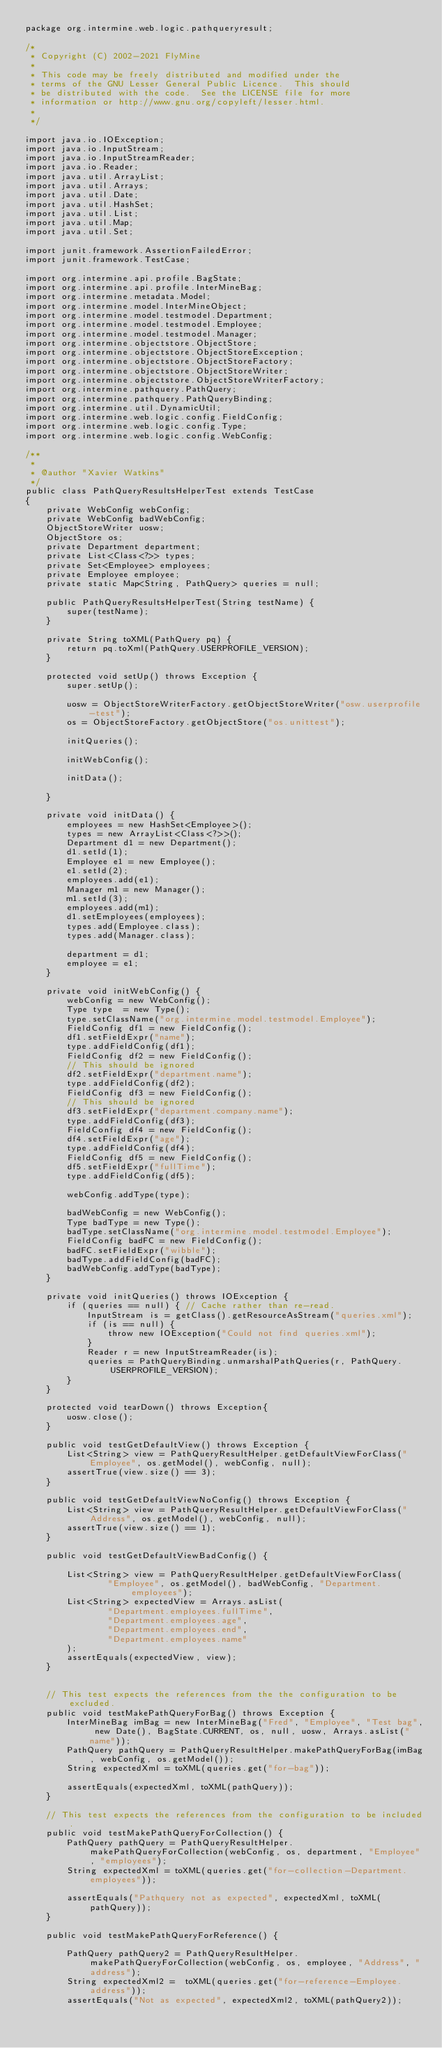<code> <loc_0><loc_0><loc_500><loc_500><_Java_>package org.intermine.web.logic.pathqueryresult;

/*
 * Copyright (C) 2002-2021 FlyMine
 *
 * This code may be freely distributed and modified under the
 * terms of the GNU Lesser General Public Licence.  This should
 * be distributed with the code.  See the LICENSE file for more
 * information or http://www.gnu.org/copyleft/lesser.html.
 *
 */

import java.io.IOException;
import java.io.InputStream;
import java.io.InputStreamReader;
import java.io.Reader;
import java.util.ArrayList;
import java.util.Arrays;
import java.util.Date;
import java.util.HashSet;
import java.util.List;
import java.util.Map;
import java.util.Set;

import junit.framework.AssertionFailedError;
import junit.framework.TestCase;

import org.intermine.api.profile.BagState;
import org.intermine.api.profile.InterMineBag;
import org.intermine.metadata.Model;
import org.intermine.model.InterMineObject;
import org.intermine.model.testmodel.Department;
import org.intermine.model.testmodel.Employee;
import org.intermine.model.testmodel.Manager;
import org.intermine.objectstore.ObjectStore;
import org.intermine.objectstore.ObjectStoreException;
import org.intermine.objectstore.ObjectStoreFactory;
import org.intermine.objectstore.ObjectStoreWriter;
import org.intermine.objectstore.ObjectStoreWriterFactory;
import org.intermine.pathquery.PathQuery;
import org.intermine.pathquery.PathQueryBinding;
import org.intermine.util.DynamicUtil;
import org.intermine.web.logic.config.FieldConfig;
import org.intermine.web.logic.config.Type;
import org.intermine.web.logic.config.WebConfig;

/**
 *
 * @author "Xavier Watkins"
 */
public class PathQueryResultsHelperTest extends TestCase
{
    private WebConfig webConfig;
    private WebConfig badWebConfig;
    ObjectStoreWriter uosw;
    ObjectStore os;
    private Department department;
    private List<Class<?>> types;
    private Set<Employee> employees;
    private Employee employee;
    private static Map<String, PathQuery> queries = null;

    public PathQueryResultsHelperTest(String testName) {
        super(testName);
    }

    private String toXML(PathQuery pq) {
        return pq.toXml(PathQuery.USERPROFILE_VERSION);
    }

    protected void setUp() throws Exception {
        super.setUp();

        uosw = ObjectStoreWriterFactory.getObjectStoreWriter("osw.userprofile-test");
        os = ObjectStoreFactory.getObjectStore("os.unittest");

        initQueries();

        initWebConfig();

        initData();

    }

    private void initData() {
        employees = new HashSet<Employee>();
        types = new ArrayList<Class<?>>();
        Department d1 = new Department();
        d1.setId(1);
        Employee e1 = new Employee();
        e1.setId(2);
        employees.add(e1);
        Manager m1 = new Manager();
        m1.setId(3);
        employees.add(m1);
        d1.setEmployees(employees);
        types.add(Employee.class);
        types.add(Manager.class);

        department = d1;
        employee = e1;
    }

    private void initWebConfig() {
        webConfig = new WebConfig();
        Type type  = new Type();
        type.setClassName("org.intermine.model.testmodel.Employee");
        FieldConfig df1 = new FieldConfig();
        df1.setFieldExpr("name");
        type.addFieldConfig(df1);
        FieldConfig df2 = new FieldConfig();
        // This should be ignored
        df2.setFieldExpr("department.name");
        type.addFieldConfig(df2);
        FieldConfig df3 = new FieldConfig();
        // This should be ignored
        df3.setFieldExpr("department.company.name");
        type.addFieldConfig(df3);
        FieldConfig df4 = new FieldConfig();
        df4.setFieldExpr("age");
        type.addFieldConfig(df4);
        FieldConfig df5 = new FieldConfig();
        df5.setFieldExpr("fullTime");
        type.addFieldConfig(df5);

        webConfig.addType(type);

        badWebConfig = new WebConfig();
        Type badType = new Type();
        badType.setClassName("org.intermine.model.testmodel.Employee");
        FieldConfig badFC = new FieldConfig();
        badFC.setFieldExpr("wibble");
        badType.addFieldConfig(badFC);
        badWebConfig.addType(badType);
    }

    private void initQueries() throws IOException {
        if (queries == null) { // Cache rather than re-read.
            InputStream is = getClass().getResourceAsStream("queries.xml");
            if (is == null) {
                throw new IOException("Could not find queries.xml");
            }
            Reader r = new InputStreamReader(is);
            queries = PathQueryBinding.unmarshalPathQueries(r, PathQuery.USERPROFILE_VERSION);
        }
    }

    protected void tearDown() throws Exception{
        uosw.close();
    }

    public void testGetDefaultView() throws Exception {
        List<String> view = PathQueryResultHelper.getDefaultViewForClass("Employee", os.getModel(), webConfig, null);
        assertTrue(view.size() == 3);
    }

    public void testGetDefaultViewNoConfig() throws Exception {
        List<String> view = PathQueryResultHelper.getDefaultViewForClass("Address", os.getModel(), webConfig, null);
        assertTrue(view.size() == 1);
    }

    public void testGetDefaultViewBadConfig() {

        List<String> view = PathQueryResultHelper.getDefaultViewForClass(
                "Employee", os.getModel(), badWebConfig, "Department.employees");
        List<String> expectedView = Arrays.asList(
                "Department.employees.fullTime",
                "Department.employees.age",
                "Department.employees.end",
                "Department.employees.name"
        );
        assertEquals(expectedView, view);
    }


    // This test expects the references from the the configuration to be excluded.
    public void testMakePathQueryForBag() throws Exception {
        InterMineBag imBag = new InterMineBag("Fred", "Employee", "Test bag", new Date(), BagState.CURRENT, os, null, uosw, Arrays.asList("name"));
        PathQuery pathQuery = PathQueryResultHelper.makePathQueryForBag(imBag, webConfig, os.getModel());
        String expectedXml = toXML(queries.get("for-bag"));

        assertEquals(expectedXml, toXML(pathQuery));
    }

    // This test expects the references from the configuration to be included.
    public void testMakePathQueryForCollection() {
        PathQuery pathQuery = PathQueryResultHelper.makePathQueryForCollection(webConfig, os, department, "Employee", "employees");
        String expectedXml = toXML(queries.get("for-collection-Department.employees"));

        assertEquals("Pathquery not as expected", expectedXml, toXML(pathQuery));
    }

    public void testMakePathQueryForReference() {

        PathQuery pathQuery2 = PathQueryResultHelper.makePathQueryForCollection(webConfig, os, employee, "Address", "address");
        String expectedXml2 =  toXML(queries.get("for-reference-Employee.address"));
        assertEquals("Not as expected", expectedXml2, toXML(pathQuery2));</code> 